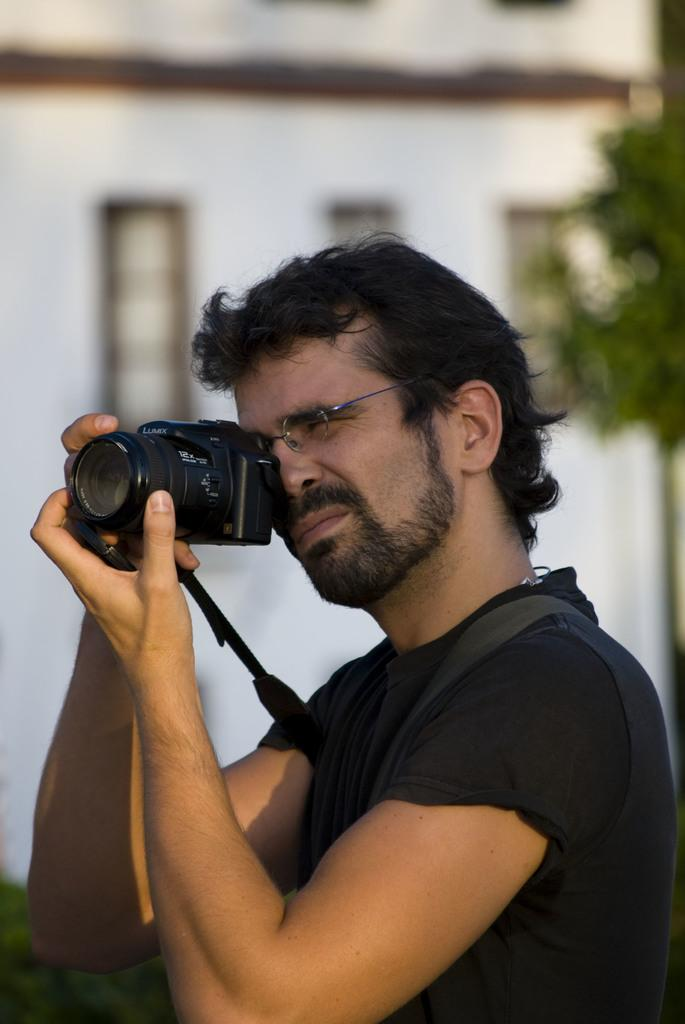What is the main subject of the image? There is a person in the image. What is the person doing in the image? The person is holding a camera with both hands. What can be seen in the background of the image? There is a tree and a building in the background of the image. What type of knife is the person using to cut the substance in the image? There is no knife or substance present in the image; the person is holding a camera. 